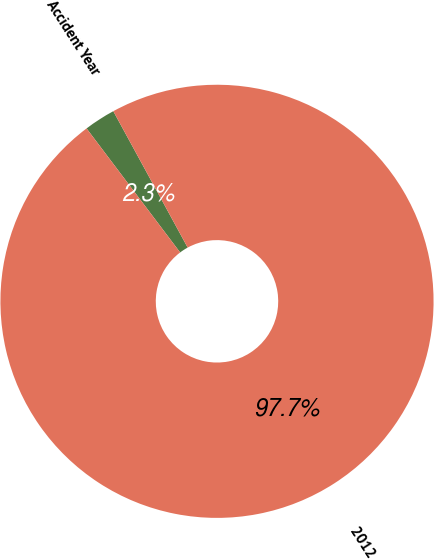<chart> <loc_0><loc_0><loc_500><loc_500><pie_chart><fcel>Accident Year<fcel>2012<nl><fcel>2.34%<fcel>97.66%<nl></chart> 